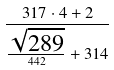<formula> <loc_0><loc_0><loc_500><loc_500>\frac { 3 1 7 \cdot 4 + 2 } { \frac { \sqrt { 2 8 9 } } { 4 4 2 } + 3 1 4 }</formula> 